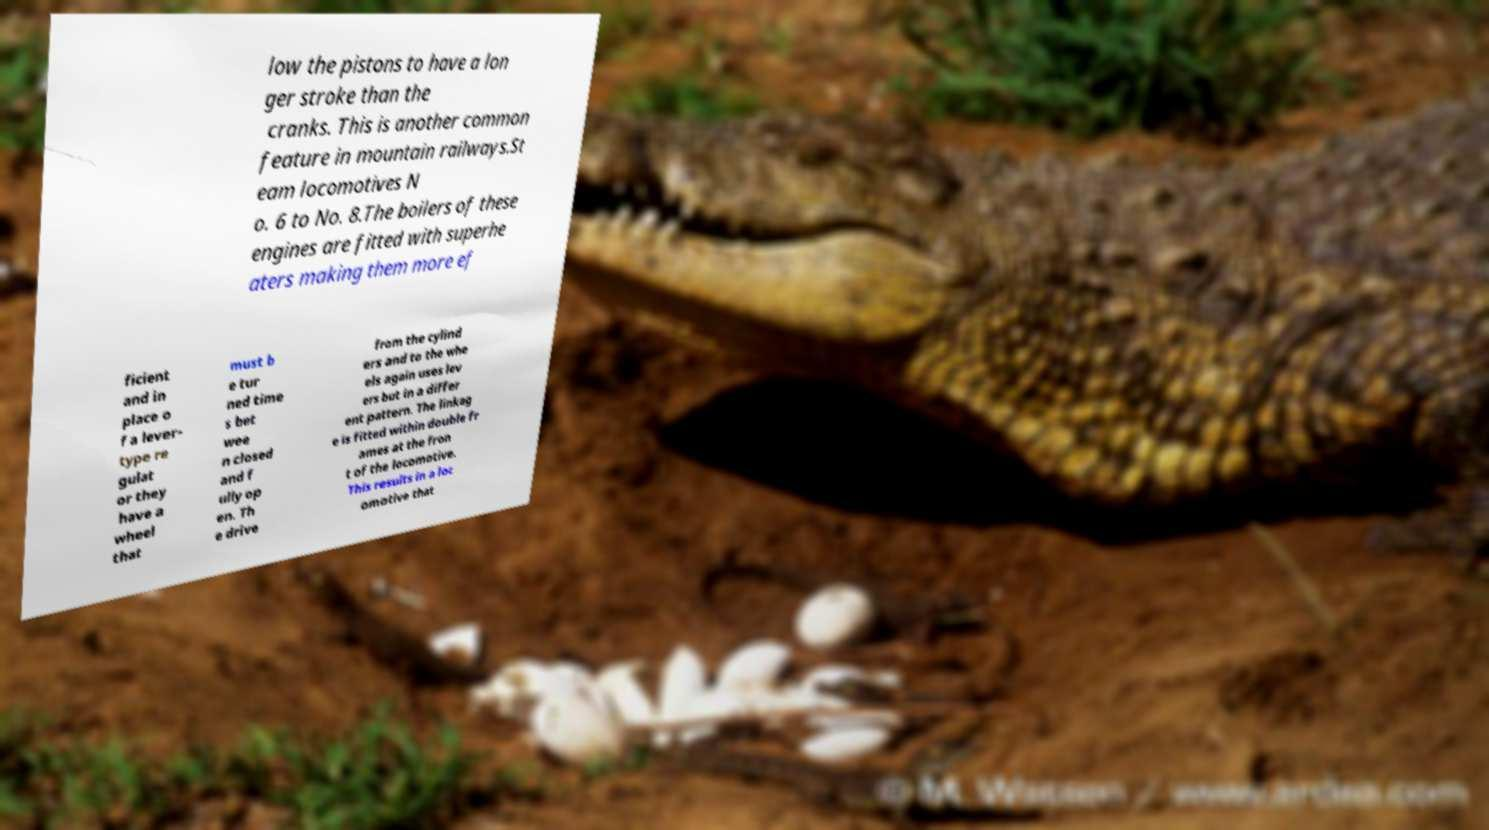Could you extract and type out the text from this image? low the pistons to have a lon ger stroke than the cranks. This is another common feature in mountain railways.St eam locomotives N o. 6 to No. 8.The boilers of these engines are fitted with superhe aters making them more ef ficient and in place o f a lever- type re gulat or they have a wheel that must b e tur ned time s bet wee n closed and f ully op en. Th e drive from the cylind ers and to the whe els again uses lev ers but in a differ ent pattern. The linkag e is fitted within double fr ames at the fron t of the locomotive. This results in a loc omotive that 